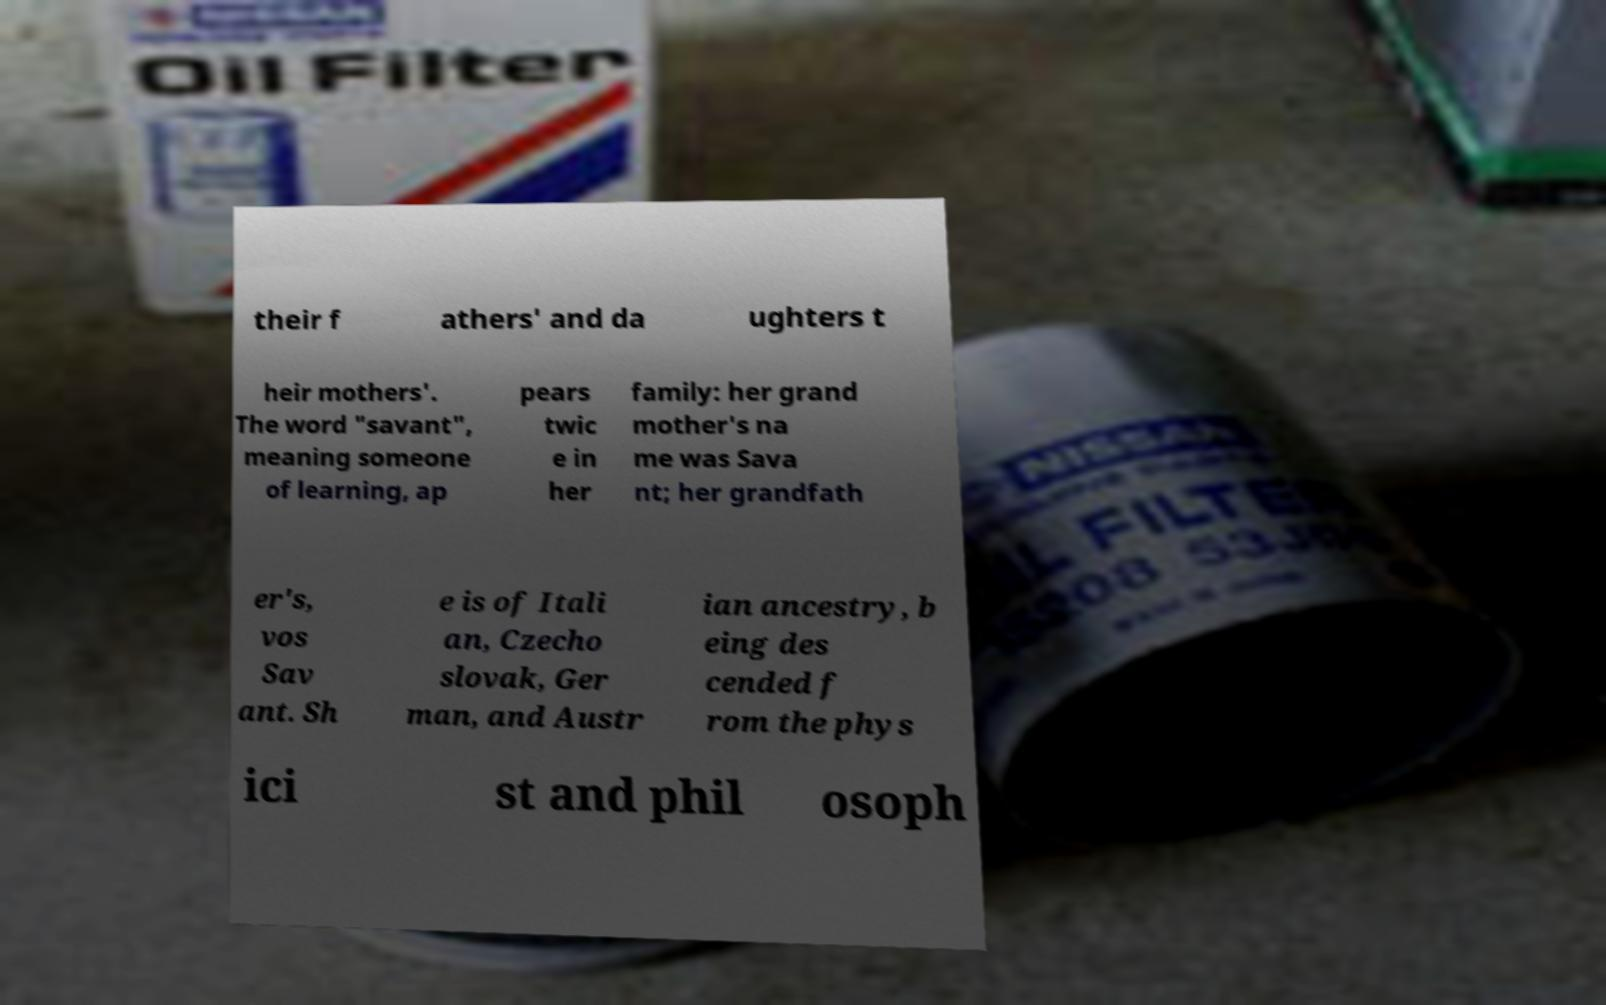I need the written content from this picture converted into text. Can you do that? their f athers' and da ughters t heir mothers'. The word "savant", meaning someone of learning, ap pears twic e in her family: her grand mother's na me was Sava nt; her grandfath er's, vos Sav ant. Sh e is of Itali an, Czecho slovak, Ger man, and Austr ian ancestry, b eing des cended f rom the phys ici st and phil osoph 